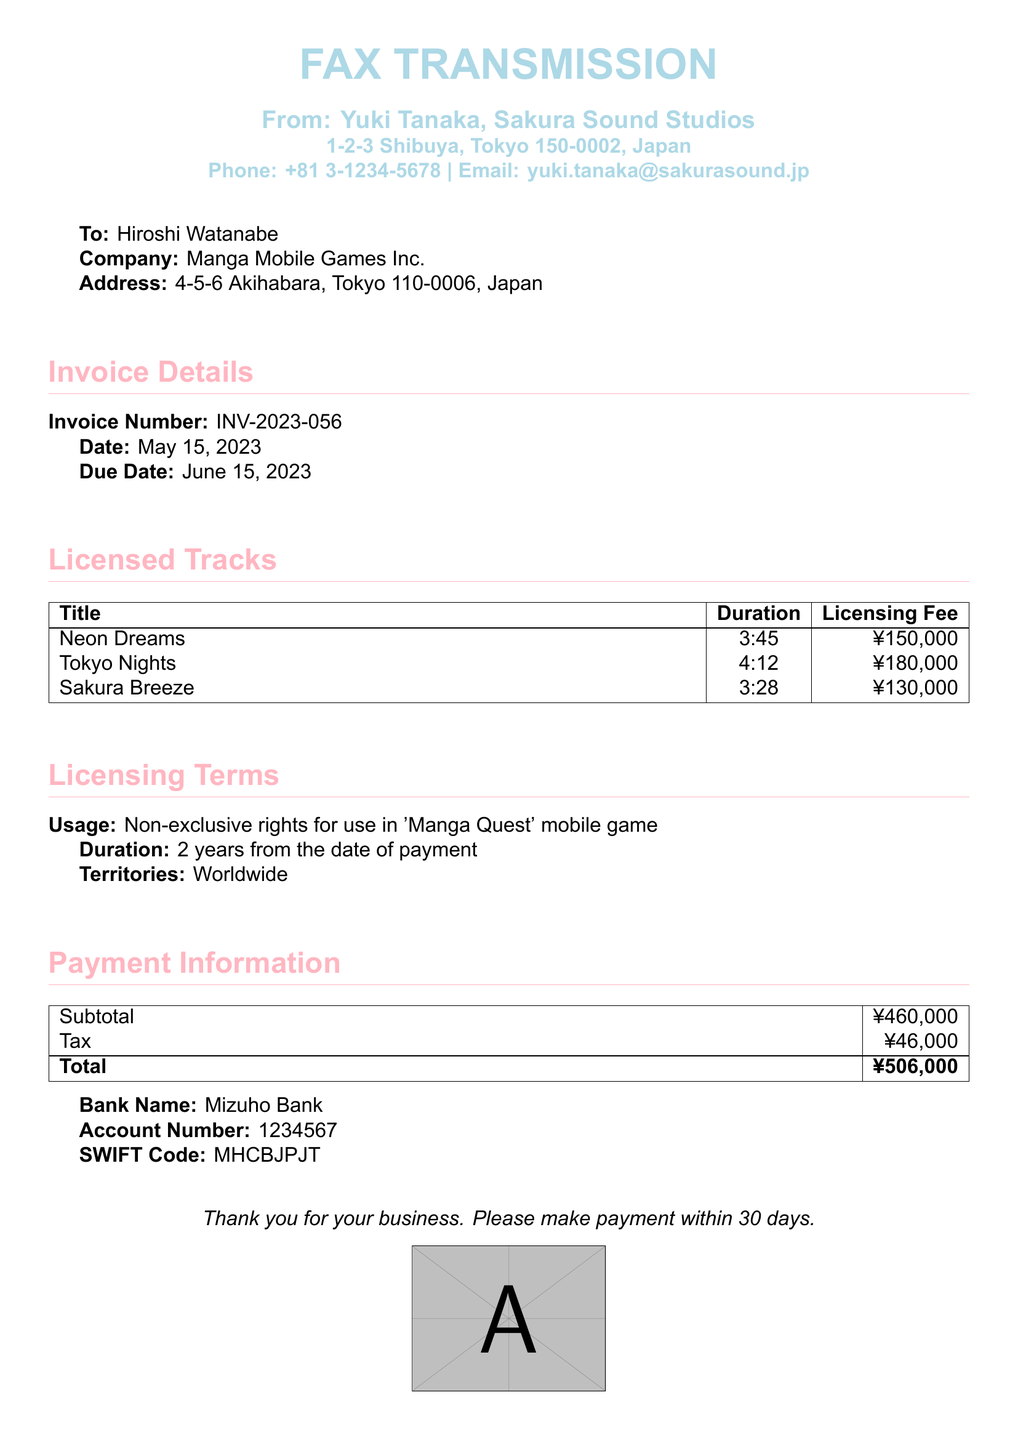What is the invoice number? The invoice number is clearly stated in the document under Invoice Details as INV-2023-056.
Answer: INV-2023-056 Who is the sender of this fax? The sender's name, Yuki Tanaka, is indicated at the top of the document.
Answer: Yuki Tanaka What is the total amount due? The total amount due is provided in the Payment Information section as the total of ¥506,000.
Answer: ¥506,000 What is the duration of the licensing agreement? The duration is mentioned in the Licensing Terms section, stating 2 years from the date of payment.
Answer: 2 years What is the licensing fee for "Tokyo Nights"? The specific licensing fee for the track "Tokyo Nights" is detailed in the Licensed Tracks table as ¥180,000.
Answer: ¥180,000 What is the due date for payment? The due date can be found in the Invoice Details section, specifically stated as June 15, 2023.
Answer: June 15, 2023 What is the usage type for the licensed tracks? The usage type is specified in the Licensing Terms as Non-exclusive rights for use in 'Manga Quest' mobile game.
Answer: Non-exclusive Which bank should the payment be made to? The bank name for payment is listed in the Payment Information section as Mizuho Bank.
Answer: Mizuho Bank How many tracks are licensed in this invoice? The number of licensed tracks is determined by counting the rows under the Licensed Tracks section, totaling three tracks.
Answer: three 